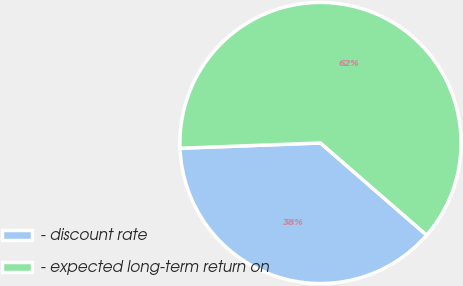<chart> <loc_0><loc_0><loc_500><loc_500><pie_chart><fcel>- discount rate<fcel>- expected long-term return on<nl><fcel>38.02%<fcel>61.98%<nl></chart> 